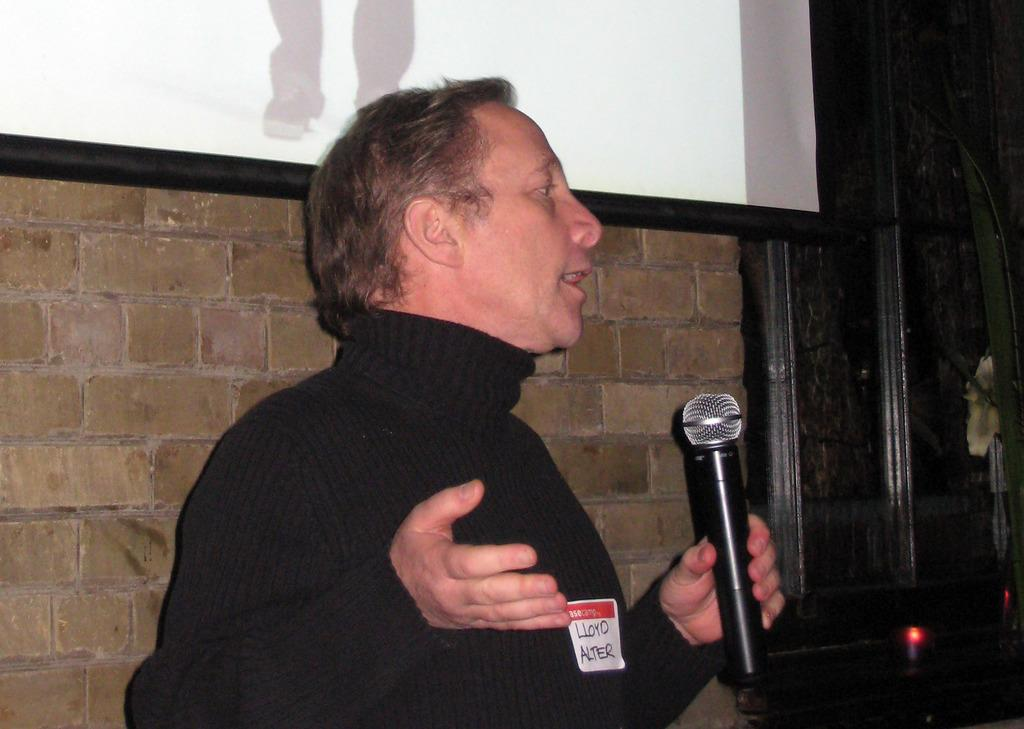What is the person in the image doing? The person is standing in the image. What is the person wearing? The person is wearing a black shirt. What object is the person holding? The person is holding a microphone. What can be seen on the wall in the background? There is a frame attached to the wall in the background. What color is the wall in the image? The wall is in brown color. How does the person in the image express their self-inflicted pain? There is no indication of self-inflicted pain or any expression of pain in the image. What type of beast can be seen in the image? There are no beasts present in the image; it features a person standing and holding a microphone. 